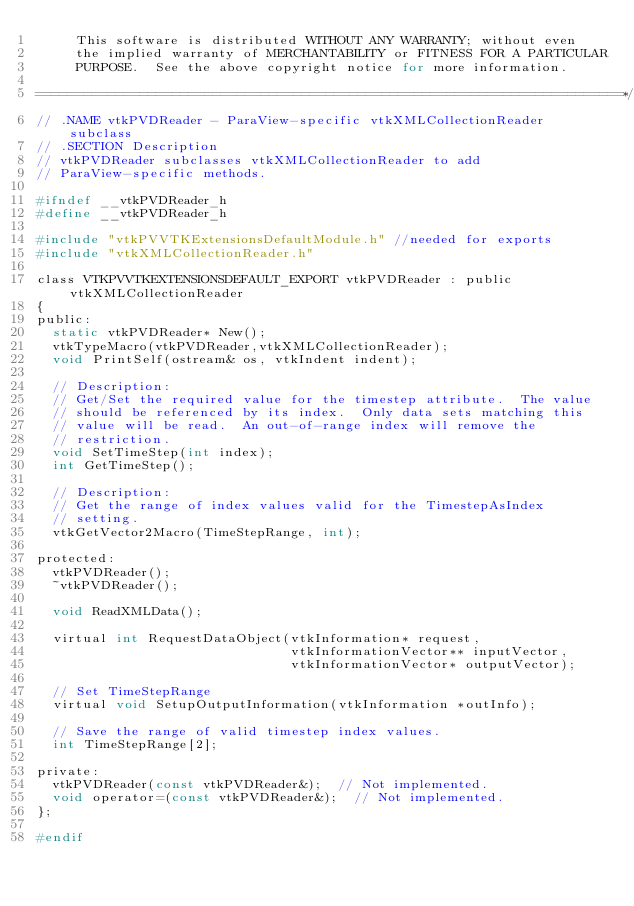<code> <loc_0><loc_0><loc_500><loc_500><_C_>     This software is distributed WITHOUT ANY WARRANTY; without even
     the implied warranty of MERCHANTABILITY or FITNESS FOR A PARTICULAR
     PURPOSE.  See the above copyright notice for more information.

=========================================================================*/
// .NAME vtkPVDReader - ParaView-specific vtkXMLCollectionReader subclass
// .SECTION Description
// vtkPVDReader subclasses vtkXMLCollectionReader to add
// ParaView-specific methods.

#ifndef __vtkPVDReader_h
#define __vtkPVDReader_h

#include "vtkPVVTKExtensionsDefaultModule.h" //needed for exports
#include "vtkXMLCollectionReader.h"

class VTKPVVTKEXTENSIONSDEFAULT_EXPORT vtkPVDReader : public vtkXMLCollectionReader
{
public:
  static vtkPVDReader* New();
  vtkTypeMacro(vtkPVDReader,vtkXMLCollectionReader);
  void PrintSelf(ostream& os, vtkIndent indent);

  // Description:
  // Get/Set the required value for the timestep attribute.  The value
  // should be referenced by its index.  Only data sets matching this
  // value will be read.  An out-of-range index will remove the
  // restriction.
  void SetTimeStep(int index);
  int GetTimeStep();

  // Description:
  // Get the range of index values valid for the TimestepAsIndex
  // setting.
  vtkGetVector2Macro(TimeStepRange, int);

protected:
  vtkPVDReader();
  ~vtkPVDReader();

  void ReadXMLData();

  virtual int RequestDataObject(vtkInformation* request, 
                                vtkInformationVector** inputVector, 
                                vtkInformationVector* outputVector);

  // Set TimeStepRange
  virtual void SetupOutputInformation(vtkInformation *outInfo);

  // Save the range of valid timestep index values.
  int TimeStepRange[2];

private:
  vtkPVDReader(const vtkPVDReader&);  // Not implemented.
  void operator=(const vtkPVDReader&);  // Not implemented.
};

#endif
</code> 